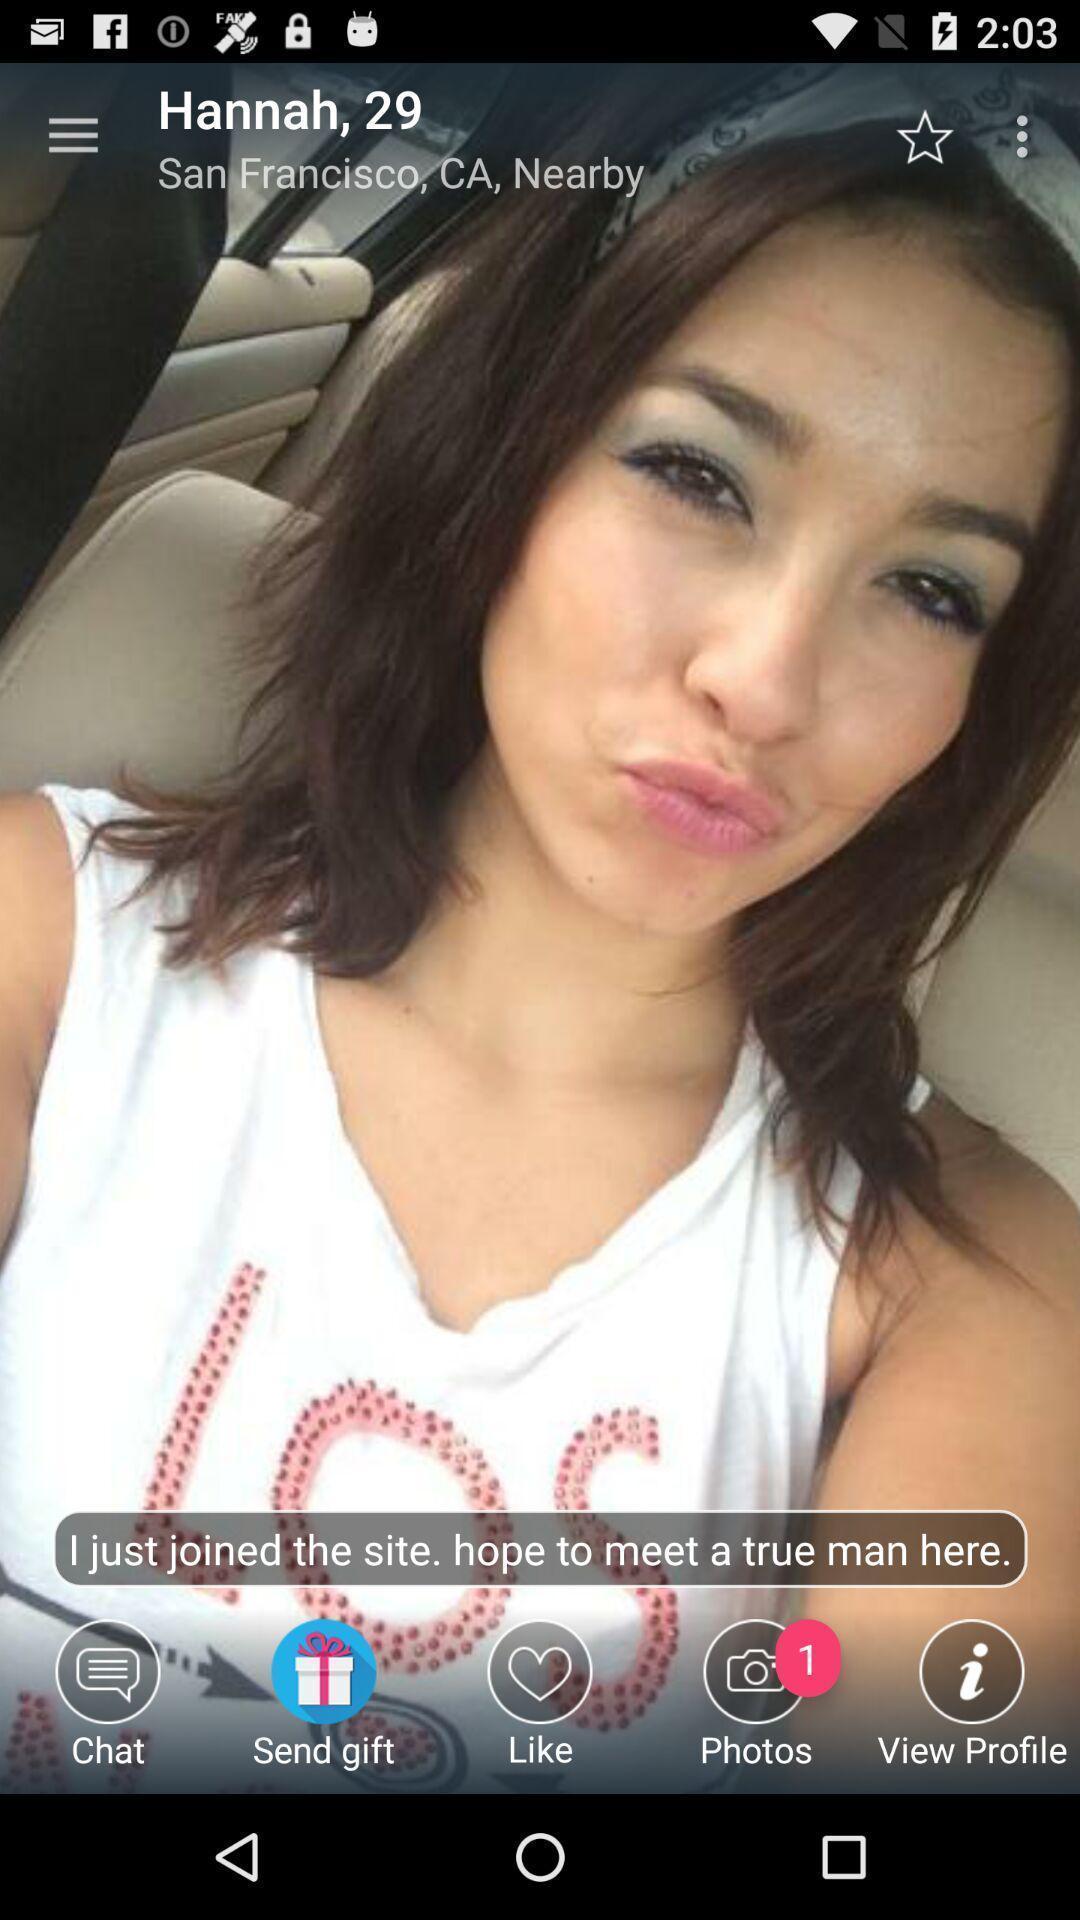Tell me what you see in this picture. Page of a dating app showing a girl profile. 